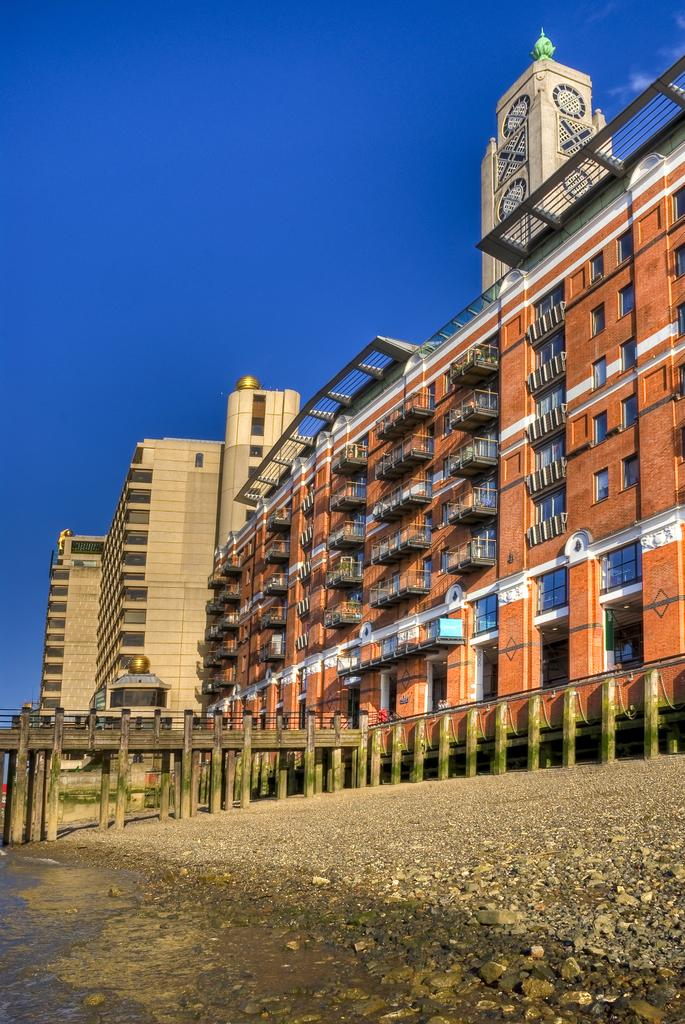What type of structure can be seen in the image? There is a bridge in the image. What else can be seen in the image besides the bridge? There are buildings in the image. What can be seen in the background of the image? The sky is visible in the background of the image. Are there any children playing on the bridge in the image? There is no information about children or any amusement or surprise in the image; it only shows a bridge and buildings with the sky in the background. 